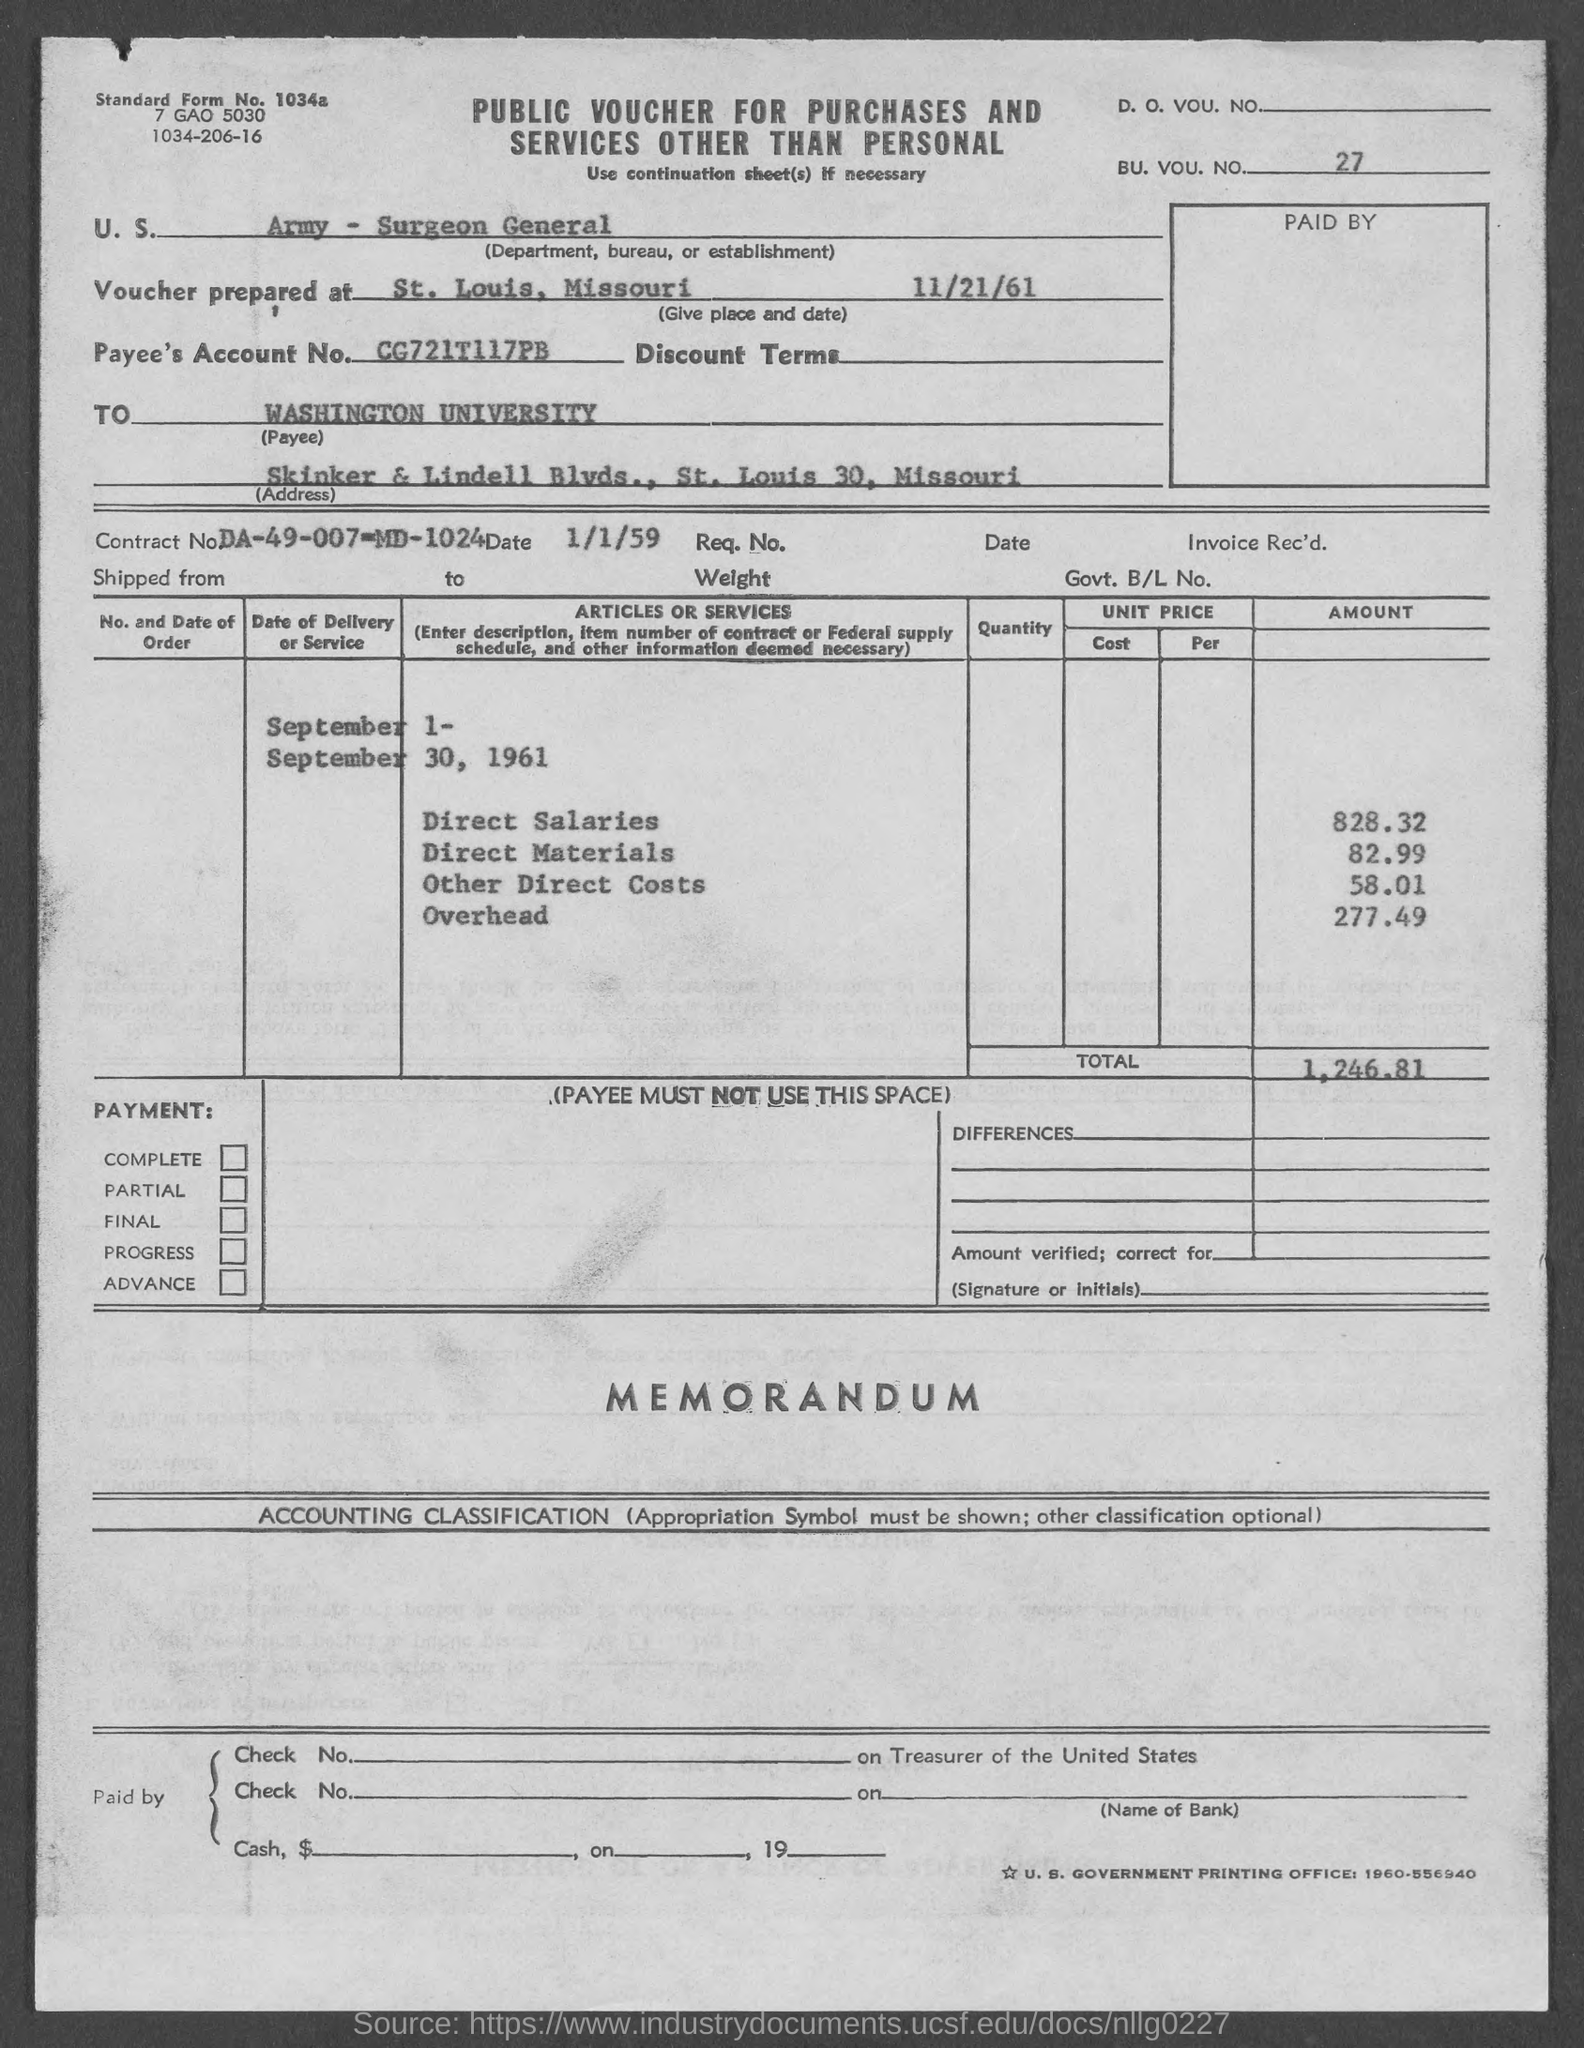what is the amount of Direct Salaries ?
 828.32 